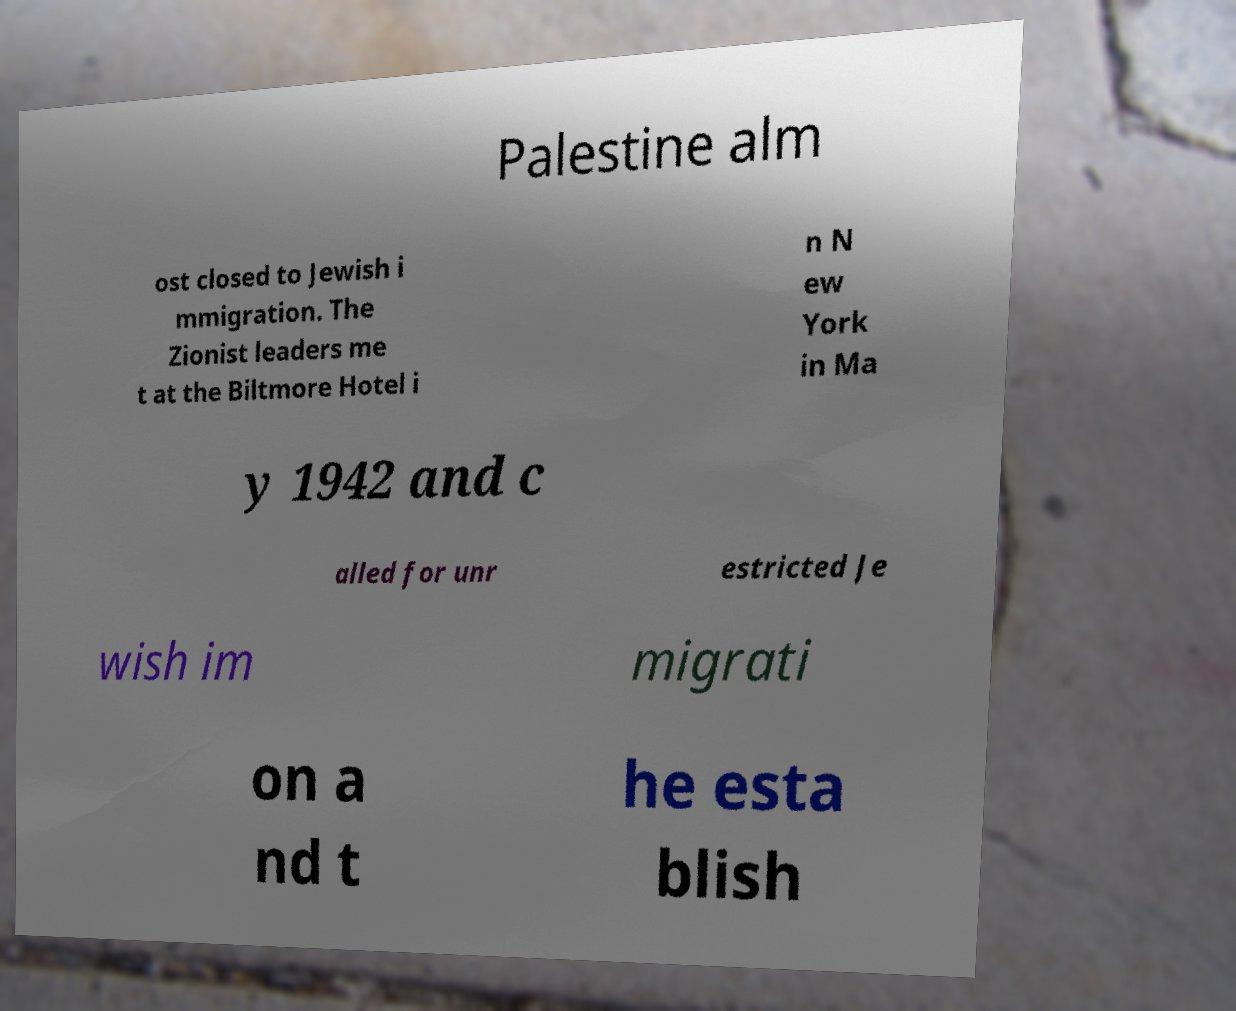For documentation purposes, I need the text within this image transcribed. Could you provide that? Palestine alm ost closed to Jewish i mmigration. The Zionist leaders me t at the Biltmore Hotel i n N ew York in Ma y 1942 and c alled for unr estricted Je wish im migrati on a nd t he esta blish 